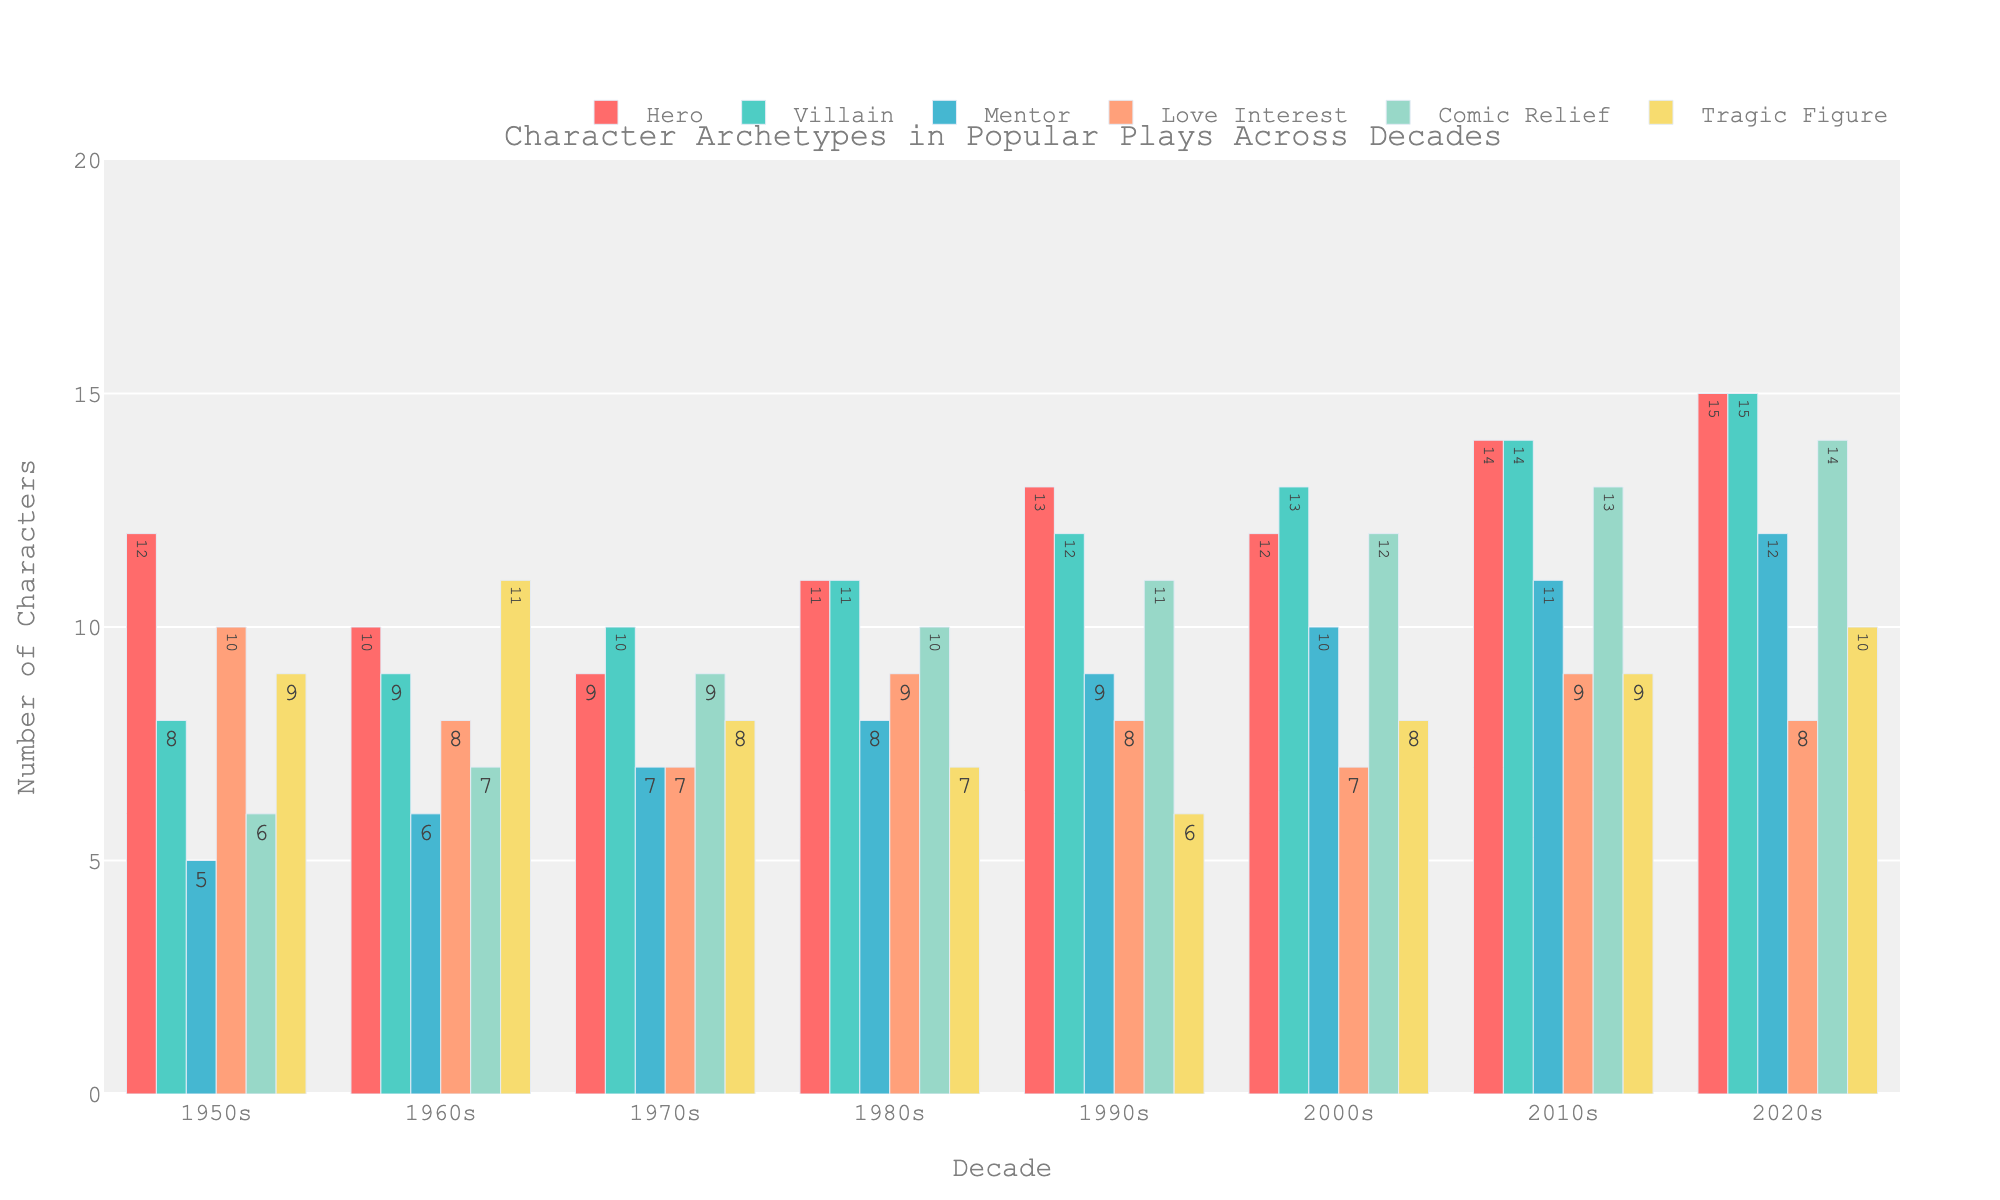What's the most common character archetype in the 2010s? Look at the bar heights for 2010s and compare them. The highest bar is for "Villain" and "Hero", both at 14.
Answer: Hero, Villain Which decade had the highest number of Mentors? Compare the heights of the bars for the Mentor archetype across all decades. The highest bar is in the 2020s, with 12 Mentors.
Answer: 2020s Did the number of Comic Relief characters increase or decrease from the 1950s to the 2020s? Compare the heights of the Comic Relief bars in 1950s (6) to 2020s (14). There's an increase.
Answer: Increase Which decade had the fewest Love Interest characters? Compare the bar heights for the Love Interest character across all decades. The fewest number is during the 2000s with 7.
Answer: 2000s How does the number of Tragic Figures in the 1980s compare to the 2010s? Look at the heights of the Tragic Figures bars for both decades. The 1980s had 7 Tragic Figures, while the 2010s had 9, so the 2010s had more.
Answer: Fewer in 1980s What is the trend in the number of Heroes from the 1950s to the 2020s? Observe the heights of the Hero bars from 1950s to 2020s. The bars show an increasing trend.
Answer: Increasing What is the combined total of Love Interest characters in the 1990s and 2000s? Sum up the Love Interest characters in the 1990s (8) and 2000s (7). 8 + 7 = 15.
Answer: 15 How does the incidence of Villains in the 1970s compare to the 1980s? Compare the Villain bars for 1970s (10) and 1980s (11). The 1980s had 1 more Villain character than the 1970s.
Answer: More in 1980s Compare the average number of Comic Relief characters from 1950s to 1990s with the average number from 2000s to 2020s. First, calculate the average for each period:
1950s-1990s: (6+7+9+10+11)/5 = 43/5 = 8.6
2000s-2020s: (12+13+14)/3 = 39/3 = 13
Answer: Lower from 1950s-1990s 